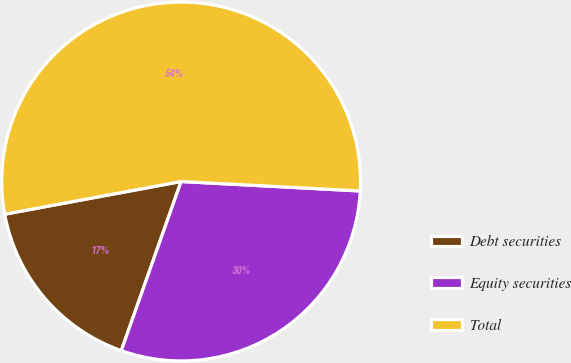Convert chart to OTSL. <chart><loc_0><loc_0><loc_500><loc_500><pie_chart><fcel>Debt securities<fcel>Equity securities<fcel>Total<nl><fcel>16.67%<fcel>29.57%<fcel>53.76%<nl></chart> 